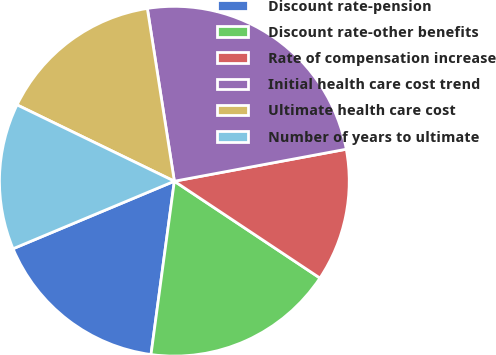<chart> <loc_0><loc_0><loc_500><loc_500><pie_chart><fcel>Discount rate-pension<fcel>Discount rate-other benefits<fcel>Rate of compensation increase<fcel>Initial health care cost trend<fcel>Ultimate health care cost<fcel>Number of years to ultimate<nl><fcel>16.56%<fcel>17.79%<fcel>12.27%<fcel>24.54%<fcel>15.34%<fcel>13.5%<nl></chart> 